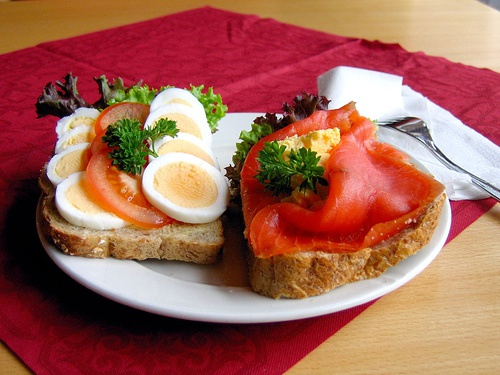Describe the objects in this image and their specific colors. I can see dining table in brown, lightgray, black, maroon, and tan tones, sandwich in olive, brown, maroon, and black tones, sandwich in olive, white, tan, and black tones, and fork in olive, gray, darkgray, lightgray, and black tones in this image. 